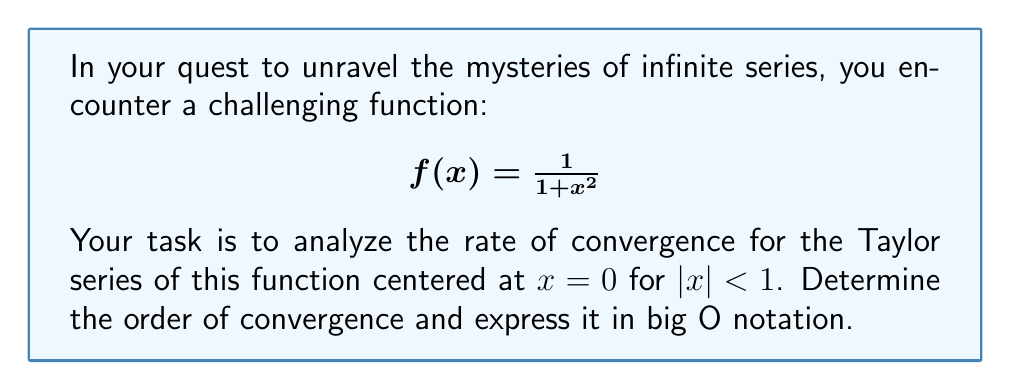Provide a solution to this math problem. To analyze the rate of convergence, we'll follow these steps:

1) First, let's recall the Taylor series for $f(x) = \frac{1}{1+x^2}$ centered at $x=0$:

   $$f(x) = 1 - x^2 + x^4 - x^6 + x^8 - ... = \sum_{n=0}^{\infty} (-1)^n x^{2n}$$

2) The error term for this series is given by the remainder:

   $$R_n(x) = f(x) - \sum_{k=0}^n (-1)^k x^{2k}$$

3) To find the order of convergence, we need to compare $R_n(x)$ with the first neglected term, which is $(-1)^{n+1} x^{2n+2}$.

4) Using Taylor's theorem with Lagrange remainder, we can express $R_n(x)$ as:

   $$R_n(x) = \frac{f^{(n+1)}(\xi)}{(n+1)!} x^{n+1}$$

   where $\xi$ is some point between 0 and $x$.

5) For our function, the $(n+1)$-th derivative is:

   $$f^{(n+1)}(x) = \frac{d^{n+1}}{dx^{n+1}} \frac{1}{1+x^2} = (-1)^{n+1} \frac{(2n+2)!}{2^{n+1}} \frac{1}{(1+x^2)^{n+2}}$$

6) Substituting this into the remainder formula:

   $$R_n(x) = (-1)^{n+1} \frac{(2n+2)!}{2^{n+1}(n+1)!} \frac{x^{2n+2}}{(1+\xi^2)^{n+2}}$$

7) Now, we can compare this to the first neglected term $(-1)^{n+1} x^{2n+2}$:

   $$\frac{R_n(x)}{(-1)^{n+1} x^{2n+2}} = \frac{(2n+2)!}{2^{n+1}(n+1)!} \frac{1}{(1+\xi^2)^{n+2}}$$

8) As $n \to \infty$, this ratio approaches a constant (not zero). This indicates that the error term is of the same order as the first neglected term.

Therefore, we can conclude that the rate of convergence is of order $O(x^{2n+2})$.
Answer: The rate of convergence for the Taylor series of $f(x) = \frac{1}{1+x^2}$ centered at $x=0$ for $|x| < 1$ is $O(x^{2n+2})$, where $n$ is the number of terms in the partial sum. 